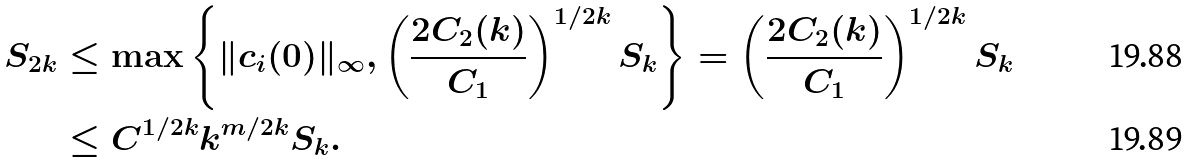<formula> <loc_0><loc_0><loc_500><loc_500>S _ { 2 k } & \leq \max \left \{ \| c _ { i } ( 0 ) \| _ { \infty } , \left ( \frac { 2 C _ { 2 } ( k ) } { C _ { 1 } } \right ) ^ { 1 / 2 k } S _ { k } \right \} = \left ( \frac { 2 C _ { 2 } ( k ) } { C _ { 1 } } \right ) ^ { 1 / 2 k } S _ { k } \\ & \leq C ^ { 1 / 2 k } k ^ { m / 2 k } S _ { k } .</formula> 